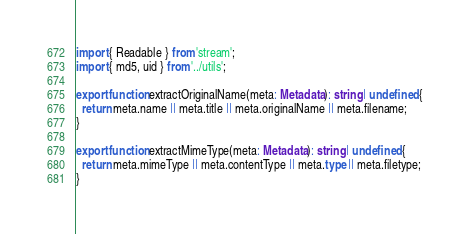<code> <loc_0><loc_0><loc_500><loc_500><_TypeScript_>import { Readable } from 'stream';
import { md5, uid } from '../utils';

export function extractOriginalName(meta: Metadata): string | undefined {
  return meta.name || meta.title || meta.originalName || meta.filename;
}

export function extractMimeType(meta: Metadata): string | undefined {
  return meta.mimeType || meta.contentType || meta.type || meta.filetype;
}
</code> 